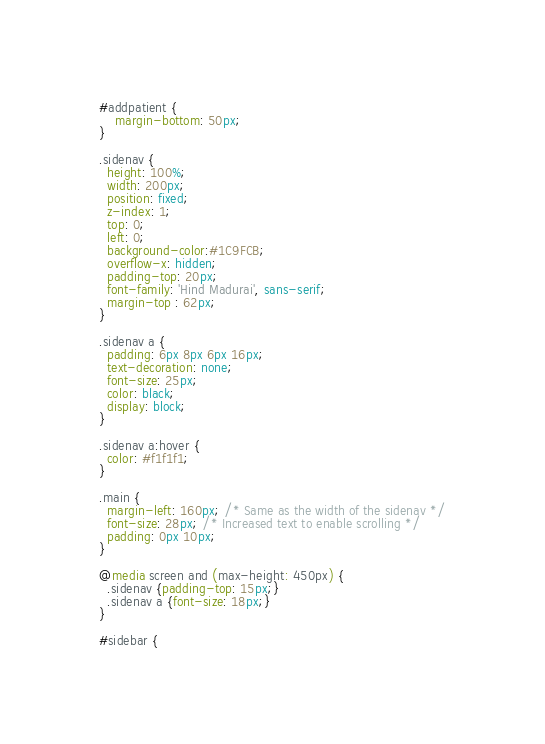Convert code to text. <code><loc_0><loc_0><loc_500><loc_500><_CSS_>
#addpatient {
	margin-bottom: 50px;
}

.sidenav {
  height: 100%;
  width: 200px;
  position: fixed;
  z-index: 1;
  top: 0;
  left: 0;
  background-color:#1C9FCB;
  overflow-x: hidden;
  padding-top: 20px;
  font-family: 'Hind Madurai', sans-serif;
  margin-top : 62px;
}

.sidenav a {
  padding: 6px 8px 6px 16px;
  text-decoration: none;
  font-size: 25px;
  color: black;
  display: block;
}

.sidenav a:hover {
  color: #f1f1f1;
}

.main {
  margin-left: 160px; /* Same as the width of the sidenav */
  font-size: 28px; /* Increased text to enable scrolling */
  padding: 0px 10px;
}

@media screen and (max-height: 450px) {
  .sidenav {padding-top: 15px;}
  .sidenav a {font-size: 18px;}
}

#sidebar {</code> 